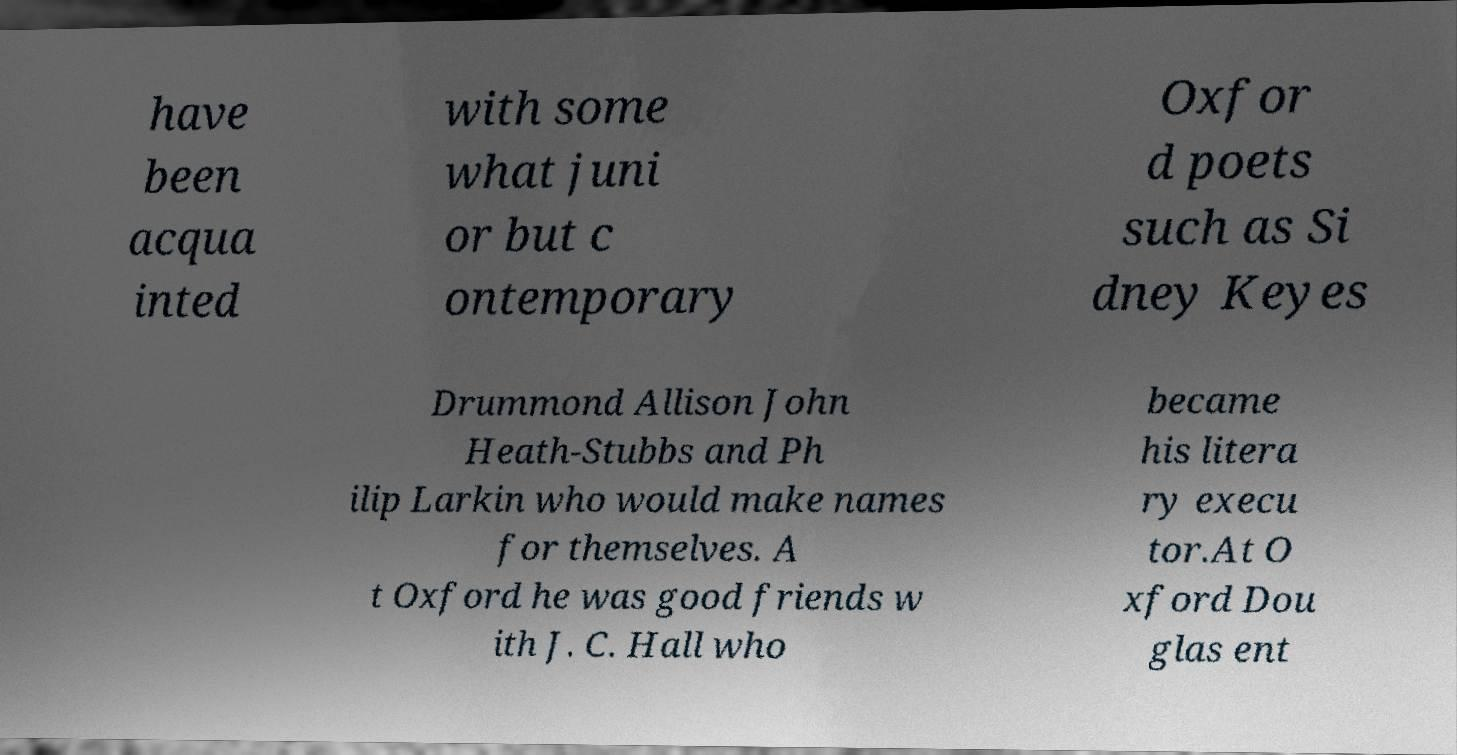For documentation purposes, I need the text within this image transcribed. Could you provide that? have been acqua inted with some what juni or but c ontemporary Oxfor d poets such as Si dney Keyes Drummond Allison John Heath-Stubbs and Ph ilip Larkin who would make names for themselves. A t Oxford he was good friends w ith J. C. Hall who became his litera ry execu tor.At O xford Dou glas ent 